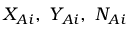Convert formula to latex. <formula><loc_0><loc_0><loc_500><loc_500>X _ { A i } , Y _ { A i } , N _ { A i }</formula> 